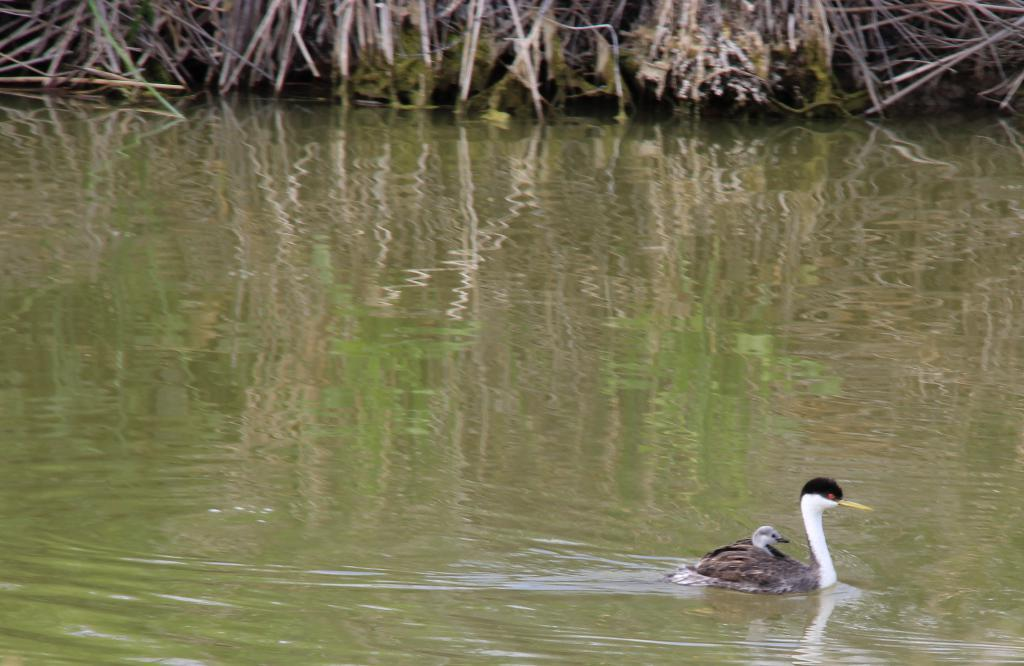What type of animals can be seen in the image? Birds can be seen in the water in the image. What is the condition of the grass visible in the image? The grass visible in the image is dry. What year is depicted in the image? The image does not depict a specific year; it is a photograph of birds in water and dry grass. 